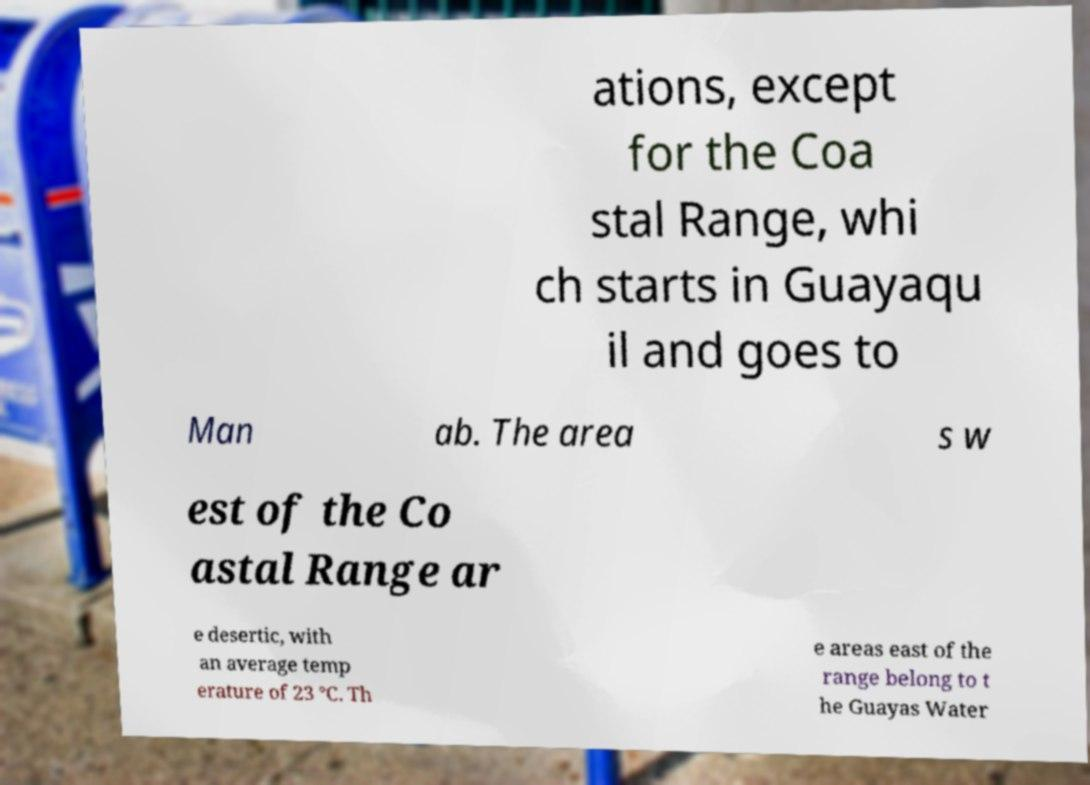For documentation purposes, I need the text within this image transcribed. Could you provide that? ations, except for the Coa stal Range, whi ch starts in Guayaqu il and goes to Man ab. The area s w est of the Co astal Range ar e desertic, with an average temp erature of 23 °C. Th e areas east of the range belong to t he Guayas Water 